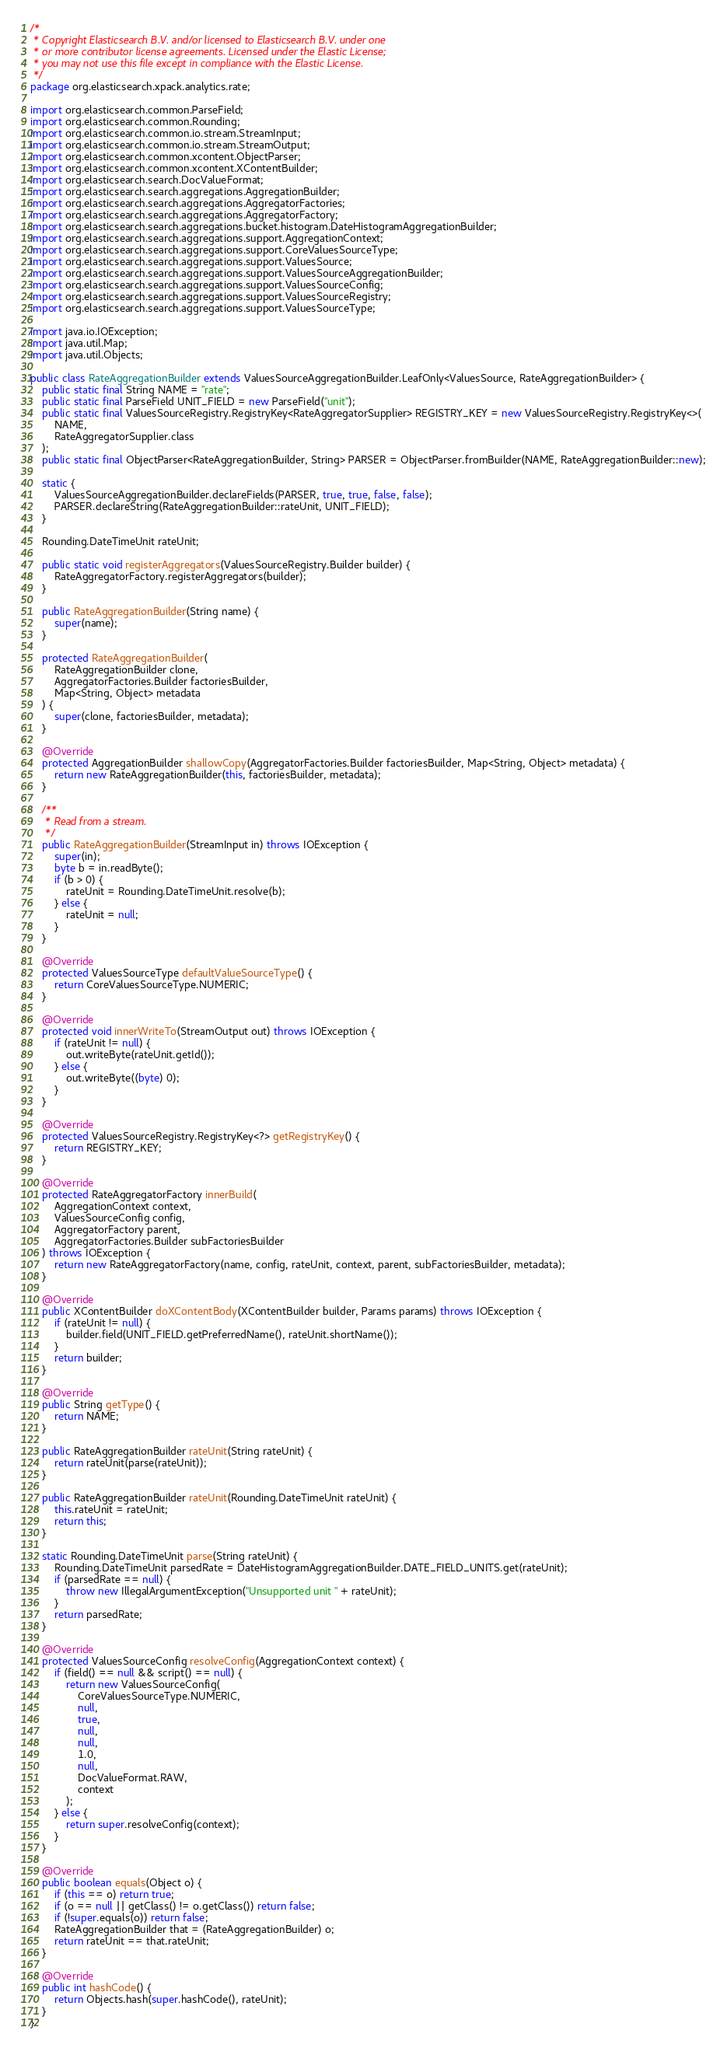Convert code to text. <code><loc_0><loc_0><loc_500><loc_500><_Java_>/*
 * Copyright Elasticsearch B.V. and/or licensed to Elasticsearch B.V. under one
 * or more contributor license agreements. Licensed under the Elastic License;
 * you may not use this file except in compliance with the Elastic License.
 */
package org.elasticsearch.xpack.analytics.rate;

import org.elasticsearch.common.ParseField;
import org.elasticsearch.common.Rounding;
import org.elasticsearch.common.io.stream.StreamInput;
import org.elasticsearch.common.io.stream.StreamOutput;
import org.elasticsearch.common.xcontent.ObjectParser;
import org.elasticsearch.common.xcontent.XContentBuilder;
import org.elasticsearch.search.DocValueFormat;
import org.elasticsearch.search.aggregations.AggregationBuilder;
import org.elasticsearch.search.aggregations.AggregatorFactories;
import org.elasticsearch.search.aggregations.AggregatorFactory;
import org.elasticsearch.search.aggregations.bucket.histogram.DateHistogramAggregationBuilder;
import org.elasticsearch.search.aggregations.support.AggregationContext;
import org.elasticsearch.search.aggregations.support.CoreValuesSourceType;
import org.elasticsearch.search.aggregations.support.ValuesSource;
import org.elasticsearch.search.aggregations.support.ValuesSourceAggregationBuilder;
import org.elasticsearch.search.aggregations.support.ValuesSourceConfig;
import org.elasticsearch.search.aggregations.support.ValuesSourceRegistry;
import org.elasticsearch.search.aggregations.support.ValuesSourceType;

import java.io.IOException;
import java.util.Map;
import java.util.Objects;

public class RateAggregationBuilder extends ValuesSourceAggregationBuilder.LeafOnly<ValuesSource, RateAggregationBuilder> {
    public static final String NAME = "rate";
    public static final ParseField UNIT_FIELD = new ParseField("unit");
    public static final ValuesSourceRegistry.RegistryKey<RateAggregatorSupplier> REGISTRY_KEY = new ValuesSourceRegistry.RegistryKey<>(
        NAME,
        RateAggregatorSupplier.class
    );
    public static final ObjectParser<RateAggregationBuilder, String> PARSER = ObjectParser.fromBuilder(NAME, RateAggregationBuilder::new);

    static {
        ValuesSourceAggregationBuilder.declareFields(PARSER, true, true, false, false);
        PARSER.declareString(RateAggregationBuilder::rateUnit, UNIT_FIELD);
    }

    Rounding.DateTimeUnit rateUnit;

    public static void registerAggregators(ValuesSourceRegistry.Builder builder) {
        RateAggregatorFactory.registerAggregators(builder);
    }

    public RateAggregationBuilder(String name) {
        super(name);
    }

    protected RateAggregationBuilder(
        RateAggregationBuilder clone,
        AggregatorFactories.Builder factoriesBuilder,
        Map<String, Object> metadata
    ) {
        super(clone, factoriesBuilder, metadata);
    }

    @Override
    protected AggregationBuilder shallowCopy(AggregatorFactories.Builder factoriesBuilder, Map<String, Object> metadata) {
        return new RateAggregationBuilder(this, factoriesBuilder, metadata);
    }

    /**
     * Read from a stream.
     */
    public RateAggregationBuilder(StreamInput in) throws IOException {
        super(in);
        byte b = in.readByte();
        if (b > 0) {
            rateUnit = Rounding.DateTimeUnit.resolve(b);
        } else {
            rateUnit = null;
        }
    }

    @Override
    protected ValuesSourceType defaultValueSourceType() {
        return CoreValuesSourceType.NUMERIC;
    }

    @Override
    protected void innerWriteTo(StreamOutput out) throws IOException {
        if (rateUnit != null) {
            out.writeByte(rateUnit.getId());
        } else {
            out.writeByte((byte) 0);
        }
    }

    @Override
    protected ValuesSourceRegistry.RegistryKey<?> getRegistryKey() {
        return REGISTRY_KEY;
    }

    @Override
    protected RateAggregatorFactory innerBuild(
        AggregationContext context,
        ValuesSourceConfig config,
        AggregatorFactory parent,
        AggregatorFactories.Builder subFactoriesBuilder
    ) throws IOException {
        return new RateAggregatorFactory(name, config, rateUnit, context, parent, subFactoriesBuilder, metadata);
    }

    @Override
    public XContentBuilder doXContentBody(XContentBuilder builder, Params params) throws IOException {
        if (rateUnit != null) {
            builder.field(UNIT_FIELD.getPreferredName(), rateUnit.shortName());
        }
        return builder;
    }

    @Override
    public String getType() {
        return NAME;
    }

    public RateAggregationBuilder rateUnit(String rateUnit) {
        return rateUnit(parse(rateUnit));
    }

    public RateAggregationBuilder rateUnit(Rounding.DateTimeUnit rateUnit) {
        this.rateUnit = rateUnit;
        return this;
    }

    static Rounding.DateTimeUnit parse(String rateUnit) {
        Rounding.DateTimeUnit parsedRate = DateHistogramAggregationBuilder.DATE_FIELD_UNITS.get(rateUnit);
        if (parsedRate == null) {
            throw new IllegalArgumentException("Unsupported unit " + rateUnit);
        }
        return parsedRate;
    }

    @Override
    protected ValuesSourceConfig resolveConfig(AggregationContext context) {
        if (field() == null && script() == null) {
            return new ValuesSourceConfig(
                CoreValuesSourceType.NUMERIC,
                null,
                true,
                null,
                null,
                1.0,
                null,
                DocValueFormat.RAW,
                context
            );
        } else {
            return super.resolveConfig(context);
        }
    }

    @Override
    public boolean equals(Object o) {
        if (this == o) return true;
        if (o == null || getClass() != o.getClass()) return false;
        if (!super.equals(o)) return false;
        RateAggregationBuilder that = (RateAggregationBuilder) o;
        return rateUnit == that.rateUnit;
    }

    @Override
    public int hashCode() {
        return Objects.hash(super.hashCode(), rateUnit);
    }
}
</code> 